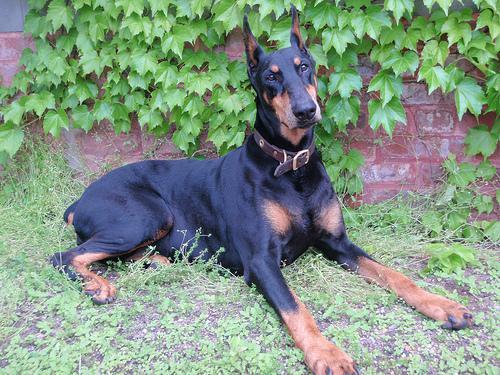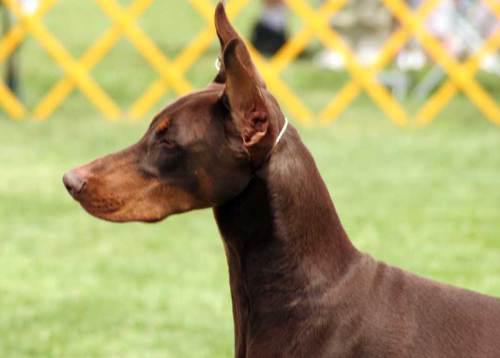The first image is the image on the left, the second image is the image on the right. Assess this claim about the two images: "One image shows one pointy-eared doberman in a collar reclining on green ground, and the other image shows one leftward-facing doberman with a closed mouth and pointy ears.". Correct or not? Answer yes or no. Yes. The first image is the image on the left, the second image is the image on the right. For the images displayed, is the sentence "One dog is reclining." factually correct? Answer yes or no. Yes. 